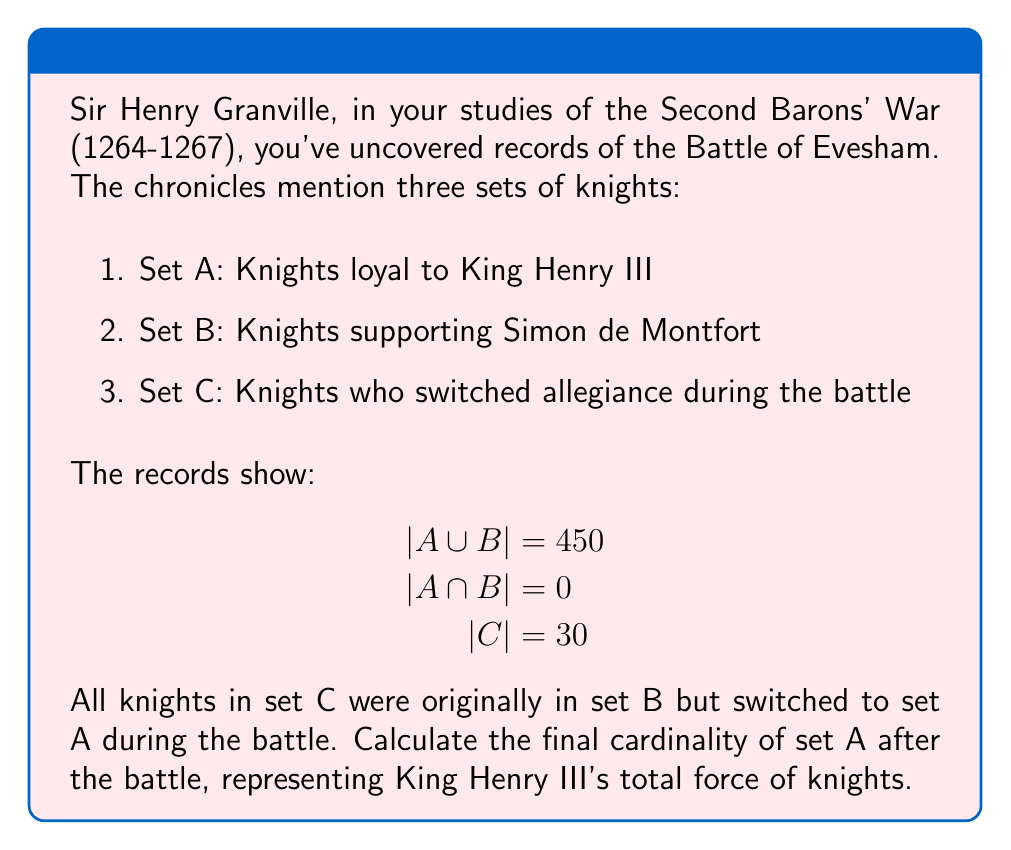Teach me how to tackle this problem. Let's approach this step-by-step:

1) First, we need to understand what each set represents:
   - Set A: Knights loyal to King Henry III
   - Set B: Knights supporting Simon de Montfort
   - Set C: Knights who switched from B to A during the battle

2) We're given that $|A \cup B| = 450$ and $|A \cap B| = 0$. This means:
   $$|A| + |B| = 450$$ (since A and B are disjoint)

3) We're also told that $|C| = 30$, and these knights moved from B to A.

4) To find the final cardinality of A, we need to:
   - Start with the original |A|
   - Add the number of knights who switched sides (|C|)

5) Let's call the original cardinality of A as x. Then:
   - Original |A| = x
   - Original |B| = 450 - x (from step 2)

6) After the battle:
   - Final |A| = x + 30
   - Final |B| = (450 - x) - 30

7) Therefore, the final cardinality of A is:
   $$x + 30$$

8) While we can't determine the exact value of x without more information, we can express the final cardinality of A in terms of the given information.
Answer: $|A| + 30$ 